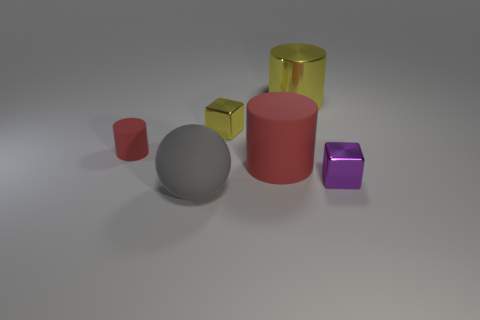Subtract all red cylinders. How many cylinders are left? 1 Subtract 1 balls. How many balls are left? 0 Subtract all red spheres. Subtract all yellow blocks. How many spheres are left? 1 Subtract all green blocks. How many red cylinders are left? 2 Subtract all gray matte things. Subtract all red objects. How many objects are left? 3 Add 6 big red cylinders. How many big red cylinders are left? 7 Add 2 big cylinders. How many big cylinders exist? 4 Add 4 tiny cyan matte cylinders. How many objects exist? 10 Subtract all purple cubes. How many cubes are left? 1 Subtract 1 gray balls. How many objects are left? 5 